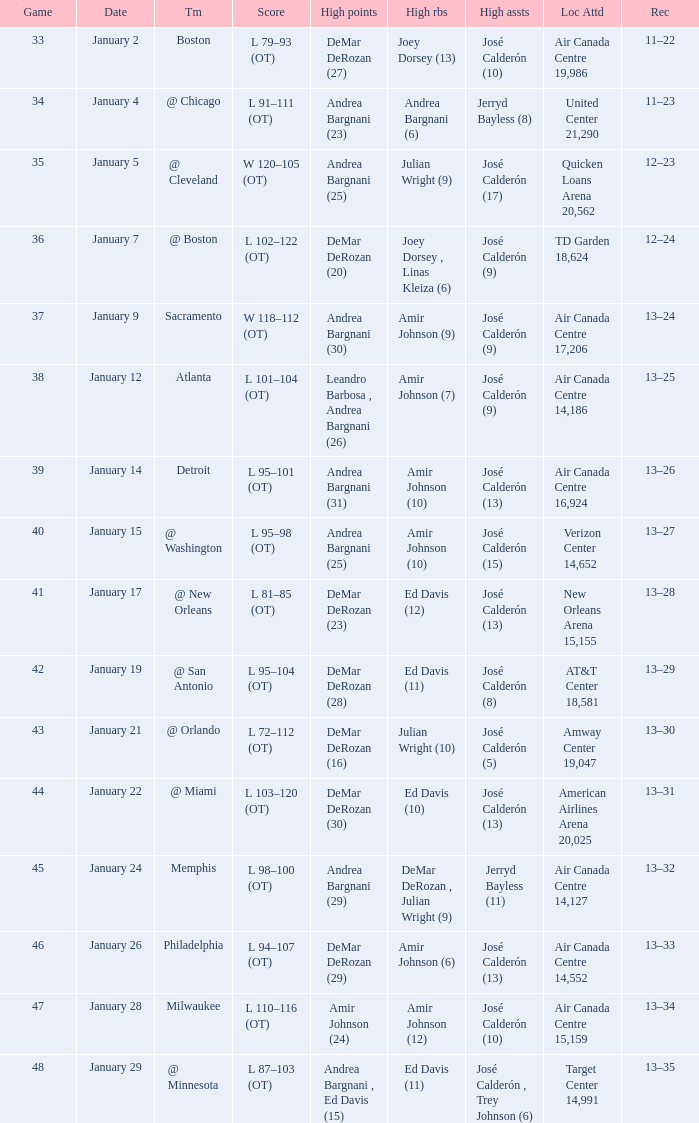Name the team for score l 102–122 (ot) @ Boston. Give me the full table as a dictionary. {'header': ['Game', 'Date', 'Tm', 'Score', 'High points', 'High rbs', 'High assts', 'Loc Attd', 'Rec'], 'rows': [['33', 'January 2', 'Boston', 'L 79–93 (OT)', 'DeMar DeRozan (27)', 'Joey Dorsey (13)', 'José Calderón (10)', 'Air Canada Centre 19,986', '11–22'], ['34', 'January 4', '@ Chicago', 'L 91–111 (OT)', 'Andrea Bargnani (23)', 'Andrea Bargnani (6)', 'Jerryd Bayless (8)', 'United Center 21,290', '11–23'], ['35', 'January 5', '@ Cleveland', 'W 120–105 (OT)', 'Andrea Bargnani (25)', 'Julian Wright (9)', 'José Calderón (17)', 'Quicken Loans Arena 20,562', '12–23'], ['36', 'January 7', '@ Boston', 'L 102–122 (OT)', 'DeMar DeRozan (20)', 'Joey Dorsey , Linas Kleiza (6)', 'José Calderón (9)', 'TD Garden 18,624', '12–24'], ['37', 'January 9', 'Sacramento', 'W 118–112 (OT)', 'Andrea Bargnani (30)', 'Amir Johnson (9)', 'José Calderón (9)', 'Air Canada Centre 17,206', '13–24'], ['38', 'January 12', 'Atlanta', 'L 101–104 (OT)', 'Leandro Barbosa , Andrea Bargnani (26)', 'Amir Johnson (7)', 'José Calderón (9)', 'Air Canada Centre 14,186', '13–25'], ['39', 'January 14', 'Detroit', 'L 95–101 (OT)', 'Andrea Bargnani (31)', 'Amir Johnson (10)', 'José Calderón (13)', 'Air Canada Centre 16,924', '13–26'], ['40', 'January 15', '@ Washington', 'L 95–98 (OT)', 'Andrea Bargnani (25)', 'Amir Johnson (10)', 'José Calderón (15)', 'Verizon Center 14,652', '13–27'], ['41', 'January 17', '@ New Orleans', 'L 81–85 (OT)', 'DeMar DeRozan (23)', 'Ed Davis (12)', 'José Calderón (13)', 'New Orleans Arena 15,155', '13–28'], ['42', 'January 19', '@ San Antonio', 'L 95–104 (OT)', 'DeMar DeRozan (28)', 'Ed Davis (11)', 'José Calderón (8)', 'AT&T Center 18,581', '13–29'], ['43', 'January 21', '@ Orlando', 'L 72–112 (OT)', 'DeMar DeRozan (16)', 'Julian Wright (10)', 'José Calderón (5)', 'Amway Center 19,047', '13–30'], ['44', 'January 22', '@ Miami', 'L 103–120 (OT)', 'DeMar DeRozan (30)', 'Ed Davis (10)', 'José Calderón (13)', 'American Airlines Arena 20,025', '13–31'], ['45', 'January 24', 'Memphis', 'L 98–100 (OT)', 'Andrea Bargnani (29)', 'DeMar DeRozan , Julian Wright (9)', 'Jerryd Bayless (11)', 'Air Canada Centre 14,127', '13–32'], ['46', 'January 26', 'Philadelphia', 'L 94–107 (OT)', 'DeMar DeRozan (29)', 'Amir Johnson (6)', 'José Calderón (13)', 'Air Canada Centre 14,552', '13–33'], ['47', 'January 28', 'Milwaukee', 'L 110–116 (OT)', 'Amir Johnson (24)', 'Amir Johnson (12)', 'José Calderón (10)', 'Air Canada Centre 15,159', '13–34'], ['48', 'January 29', '@ Minnesota', 'L 87–103 (OT)', 'Andrea Bargnani , Ed Davis (15)', 'Ed Davis (11)', 'José Calderón , Trey Johnson (6)', 'Target Center 14,991', '13–35']]} 